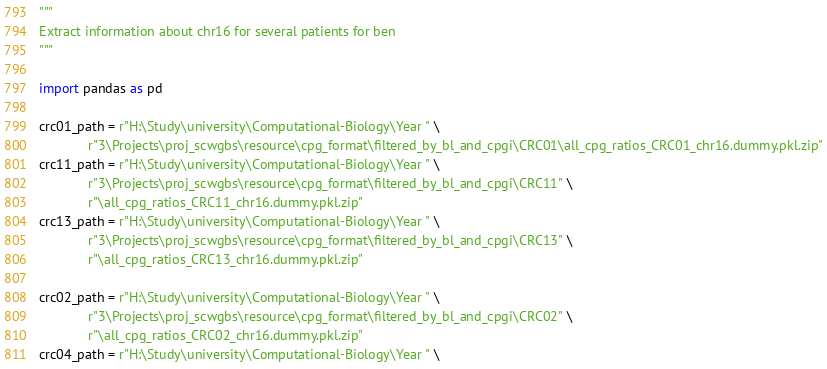Convert code to text. <code><loc_0><loc_0><loc_500><loc_500><_Python_>"""
Extract information about chr16 for several patients for ben
"""

import pandas as pd

crc01_path = r"H:\Study\university\Computational-Biology\Year " \
             r"3\Projects\proj_scwgbs\resource\cpg_format\filtered_by_bl_and_cpgi\CRC01\all_cpg_ratios_CRC01_chr16.dummy.pkl.zip"
crc11_path = r"H:\Study\university\Computational-Biology\Year " \
             r"3\Projects\proj_scwgbs\resource\cpg_format\filtered_by_bl_and_cpgi\CRC11" \
             r"\all_cpg_ratios_CRC11_chr16.dummy.pkl.zip"
crc13_path = r"H:\Study\university\Computational-Biology\Year " \
             r"3\Projects\proj_scwgbs\resource\cpg_format\filtered_by_bl_and_cpgi\CRC13" \
             r"\all_cpg_ratios_CRC13_chr16.dummy.pkl.zip"

crc02_path = r"H:\Study\university\Computational-Biology\Year " \
             r"3\Projects\proj_scwgbs\resource\cpg_format\filtered_by_bl_and_cpgi\CRC02" \
             r"\all_cpg_ratios_CRC02_chr16.dummy.pkl.zip"
crc04_path = r"H:\Study\university\Computational-Biology\Year " \</code> 